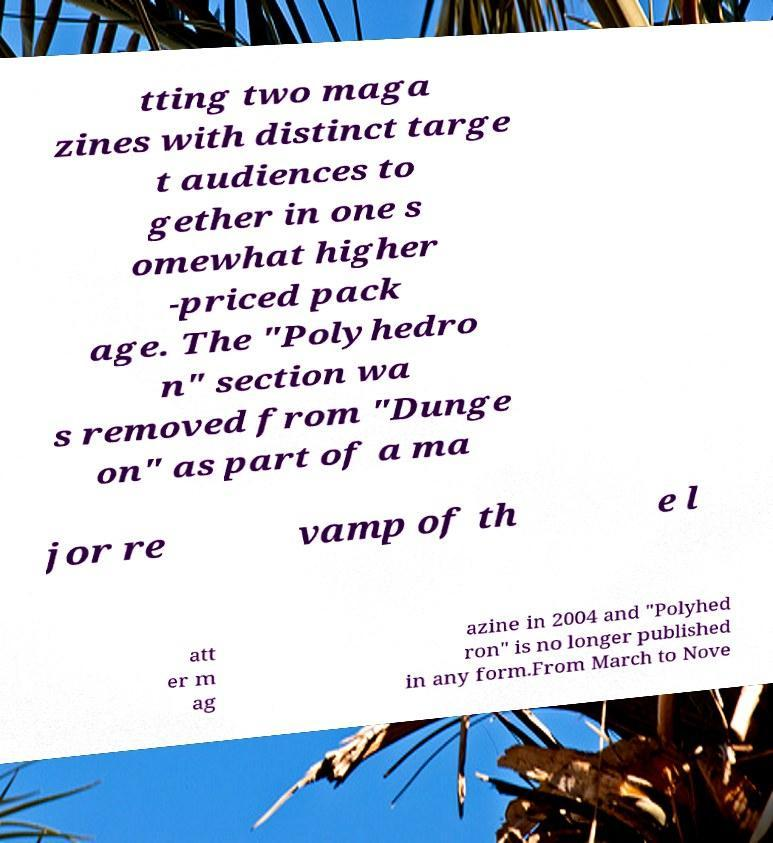Can you accurately transcribe the text from the provided image for me? tting two maga zines with distinct targe t audiences to gether in one s omewhat higher -priced pack age. The "Polyhedro n" section wa s removed from "Dunge on" as part of a ma jor re vamp of th e l att er m ag azine in 2004 and "Polyhed ron" is no longer published in any form.From March to Nove 